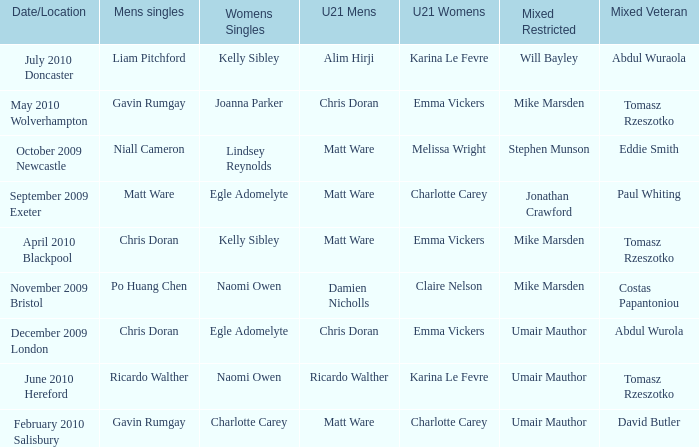Can you parse all the data within this table? {'header': ['Date/Location', 'Mens singles', 'Womens Singles', 'U21 Mens', 'U21 Womens', 'Mixed Restricted', 'Mixed Veteran'], 'rows': [['July 2010 Doncaster', 'Liam Pitchford', 'Kelly Sibley', 'Alim Hirji', 'Karina Le Fevre', 'Will Bayley', 'Abdul Wuraola'], ['May 2010 Wolverhampton', 'Gavin Rumgay', 'Joanna Parker', 'Chris Doran', 'Emma Vickers', 'Mike Marsden', 'Tomasz Rzeszotko'], ['October 2009 Newcastle', 'Niall Cameron', 'Lindsey Reynolds', 'Matt Ware', 'Melissa Wright', 'Stephen Munson', 'Eddie Smith'], ['September 2009 Exeter', 'Matt Ware', 'Egle Adomelyte', 'Matt Ware', 'Charlotte Carey', 'Jonathan Crawford', 'Paul Whiting'], ['April 2010 Blackpool', 'Chris Doran', 'Kelly Sibley', 'Matt Ware', 'Emma Vickers', 'Mike Marsden', 'Tomasz Rzeszotko'], ['November 2009 Bristol', 'Po Huang Chen', 'Naomi Owen', 'Damien Nicholls', 'Claire Nelson', 'Mike Marsden', 'Costas Papantoniou'], ['December 2009 London', 'Chris Doran', 'Egle Adomelyte', 'Chris Doran', 'Emma Vickers', 'Umair Mauthor', 'Abdul Wurola'], ['June 2010 Hereford', 'Ricardo Walther', 'Naomi Owen', 'Ricardo Walther', 'Karina Le Fevre', 'Umair Mauthor', 'Tomasz Rzeszotko'], ['February 2010 Salisbury', 'Gavin Rumgay', 'Charlotte Carey', 'Matt Ware', 'Charlotte Carey', 'Umair Mauthor', 'David Butler']]} Who was the U21 Mens winner when Mike Marsden was the mixed restricted winner and Claire Nelson was the U21 Womens winner?  Damien Nicholls. 